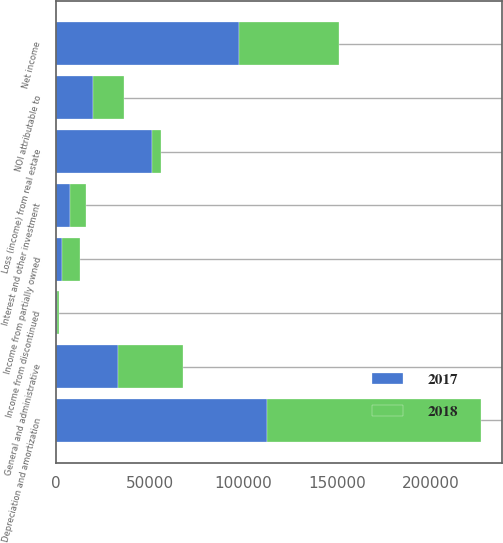Convert chart. <chart><loc_0><loc_0><loc_500><loc_500><stacked_bar_chart><ecel><fcel>Net income<fcel>Income from partially owned<fcel>Loss (income) from real estate<fcel>Interest and other investment<fcel>Income from discontinued<fcel>NOI attributable to<fcel>Depreciation and amortization<fcel>General and administrative<nl><fcel>2017<fcel>97821<fcel>3090<fcel>51258<fcel>7656<fcel>257<fcel>19771<fcel>112869<fcel>32934<nl><fcel>2018<fcel>53551<fcel>9622<fcel>4889<fcel>8294<fcel>1273<fcel>16533<fcel>114166<fcel>34916<nl></chart> 